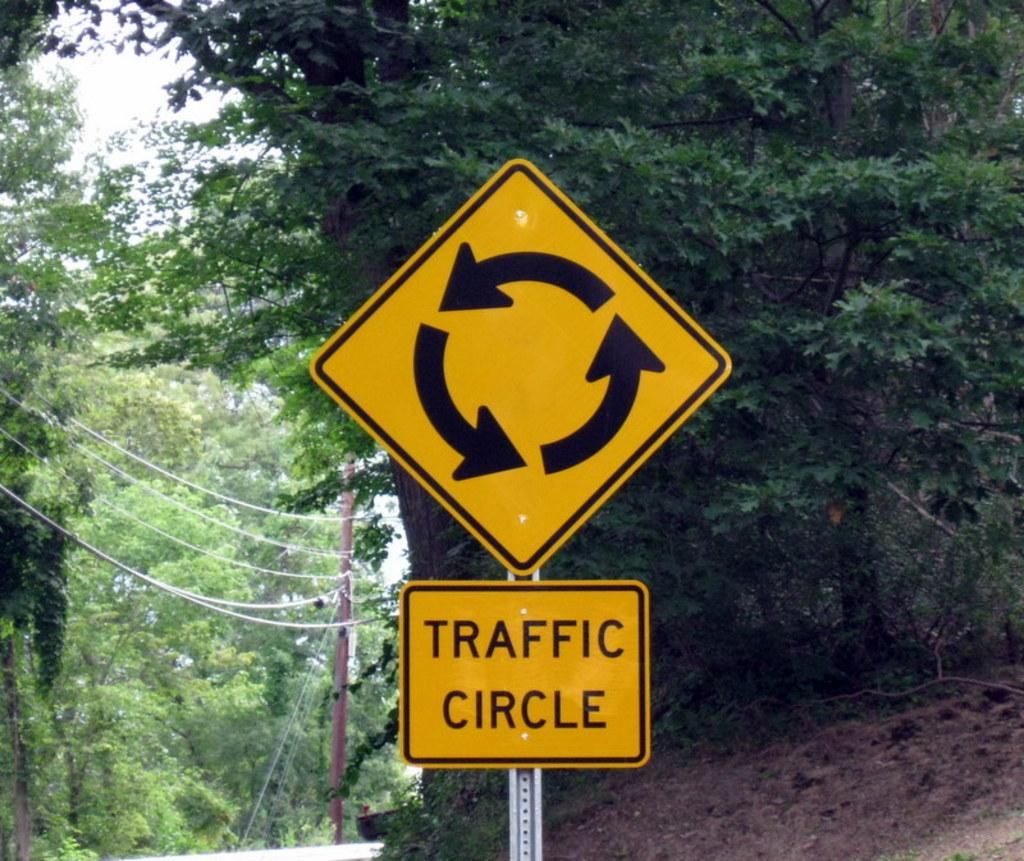<image>
Share a concise interpretation of the image provided. A sign is telling you this is a traffic circle. 